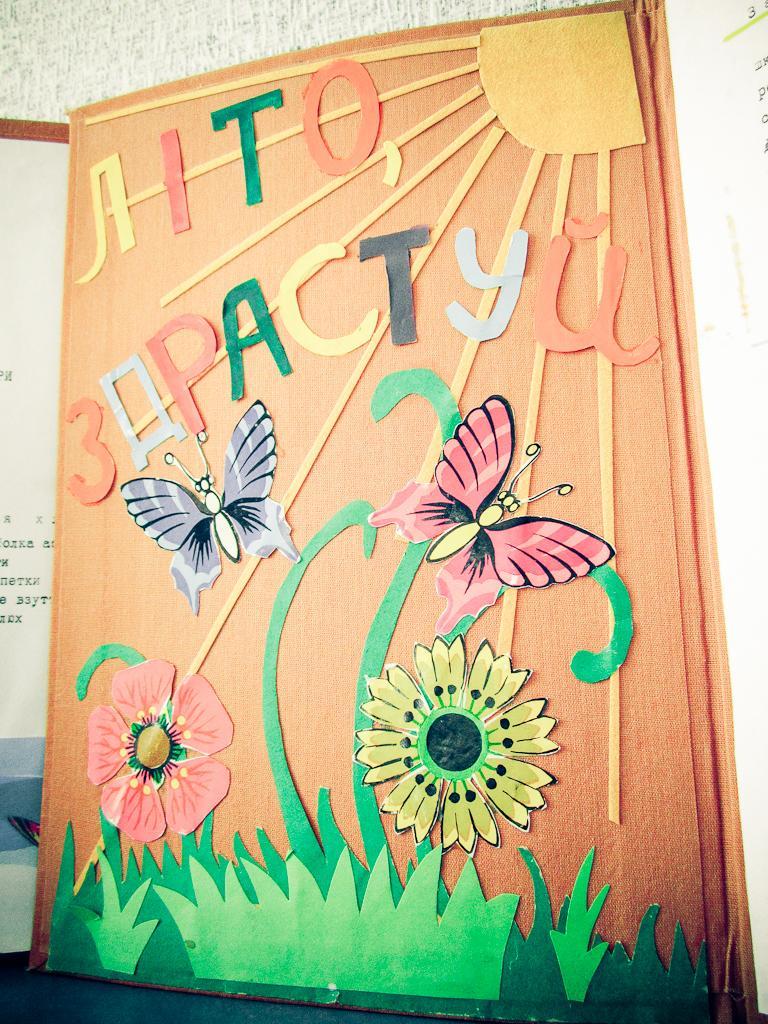Can you describe this image briefly? In this picture there are boards and there are pictures of butterflies, flowers and grass and there is text on the boards. At the back it looks like a wall. At the bottom it looks like a floor. 